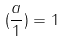Convert formula to latex. <formula><loc_0><loc_0><loc_500><loc_500>( \frac { a } { 1 } ) = 1</formula> 